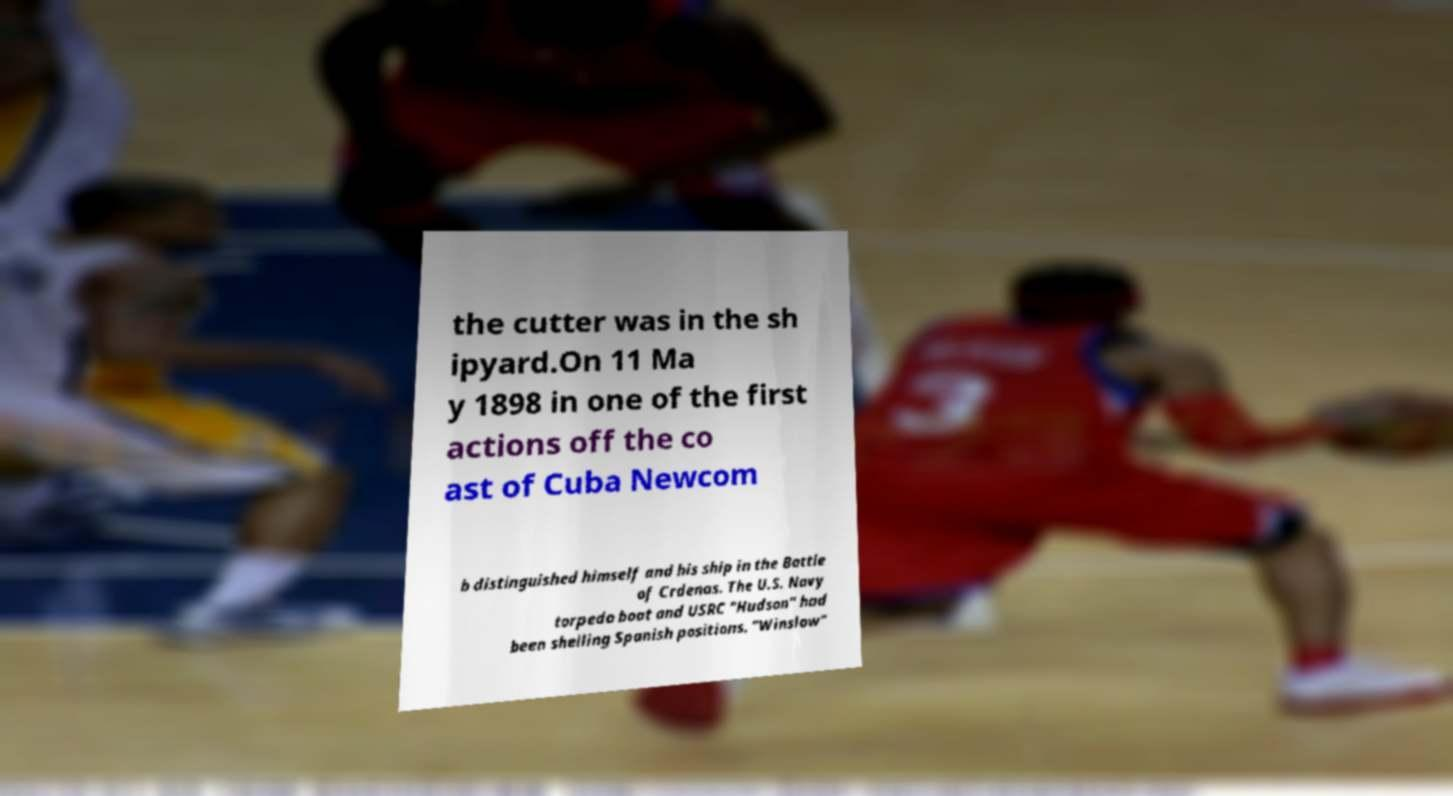Could you extract and type out the text from this image? the cutter was in the sh ipyard.On 11 Ma y 1898 in one of the first actions off the co ast of Cuba Newcom b distinguished himself and his ship in the Battle of Crdenas. The U.S. Navy torpedo boat and USRC "Hudson" had been shelling Spanish positions. "Winslow" 